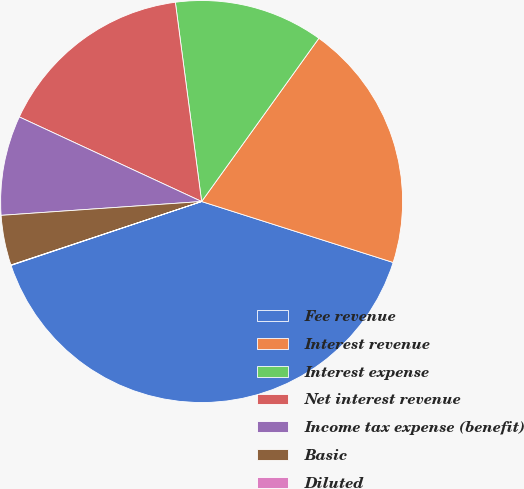<chart> <loc_0><loc_0><loc_500><loc_500><pie_chart><fcel>Fee revenue<fcel>Interest revenue<fcel>Interest expense<fcel>Net interest revenue<fcel>Income tax expense (benefit)<fcel>Basic<fcel>Diluted<nl><fcel>39.95%<fcel>19.99%<fcel>12.0%<fcel>16.0%<fcel>8.01%<fcel>4.02%<fcel>0.03%<nl></chart> 